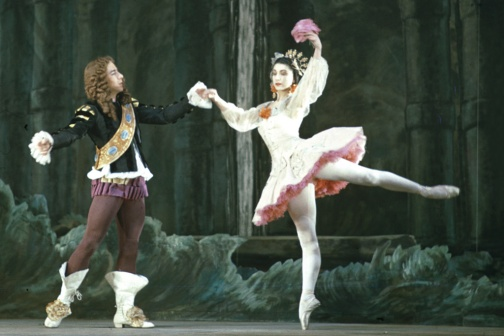Can you describe the mood and atmosphere of the performance in the image? The mood of the performance captured in the image is one of enchanting elegance and dramatic intensity. The dim, cave-like setting with its rugged rocky backdrop introduces a sense of mystique and otherworldliness. The dancers, with their poised and graceful movements, add an element of romance and narrative depth. The male dancer's inviting posture and the female dancer's mid-leap form create a powerful dynamic, suggesting a moment of passionate exchange in the story. Overall, the atmosphere is a beautiful blend of magic, drama, and refined artistry. 